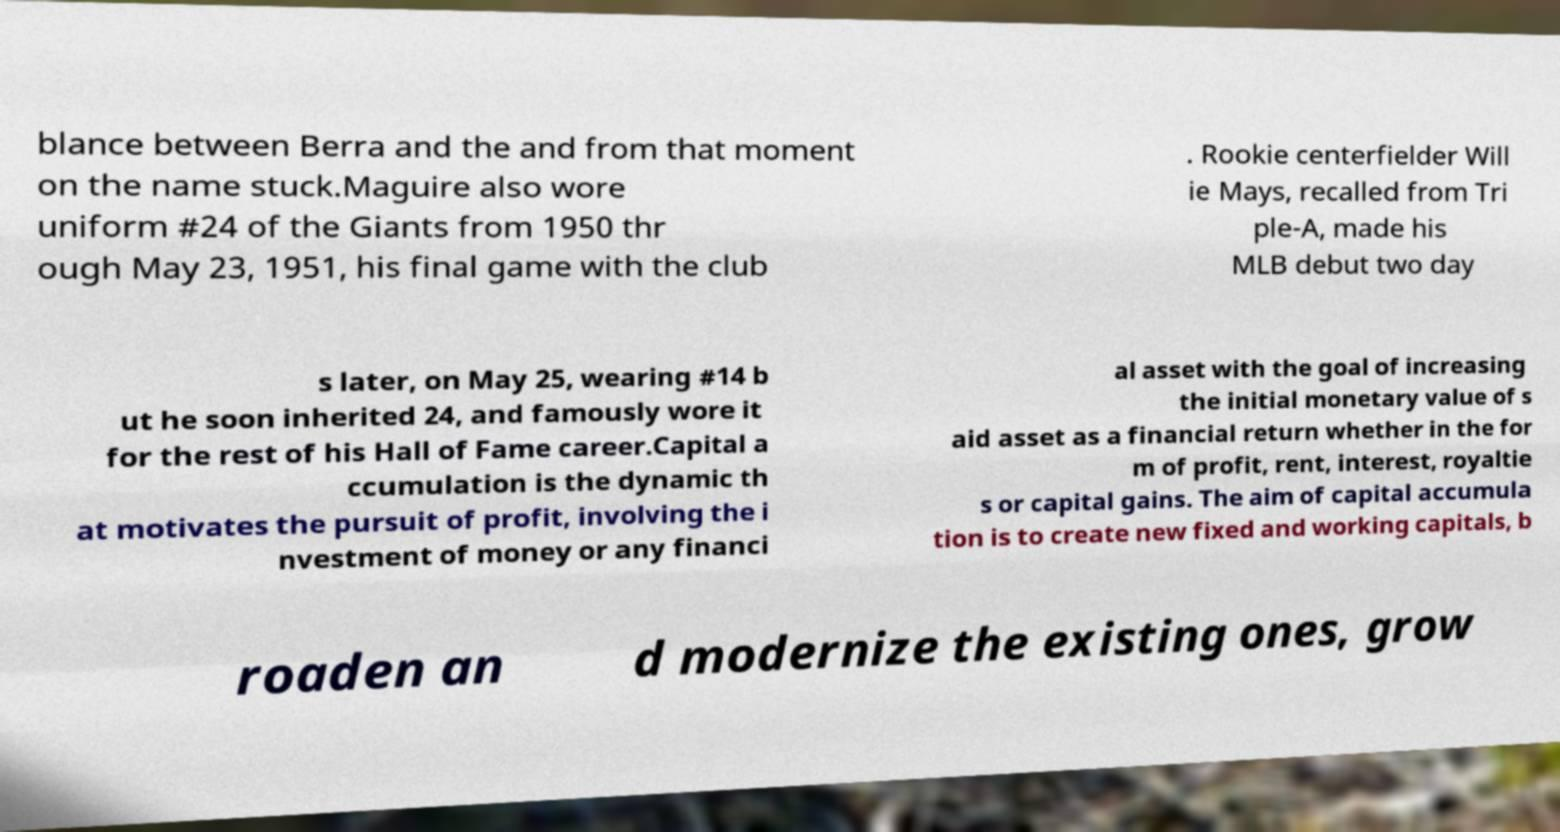Could you assist in decoding the text presented in this image and type it out clearly? blance between Berra and the and from that moment on the name stuck.Maguire also wore uniform #24 of the Giants from 1950 thr ough May 23, 1951, his final game with the club . Rookie centerfielder Will ie Mays, recalled from Tri ple-A, made his MLB debut two day s later, on May 25, wearing #14 b ut he soon inherited 24, and famously wore it for the rest of his Hall of Fame career.Capital a ccumulation is the dynamic th at motivates the pursuit of profit, involving the i nvestment of money or any financi al asset with the goal of increasing the initial monetary value of s aid asset as a financial return whether in the for m of profit, rent, interest, royaltie s or capital gains. The aim of capital accumula tion is to create new fixed and working capitals, b roaden an d modernize the existing ones, grow 